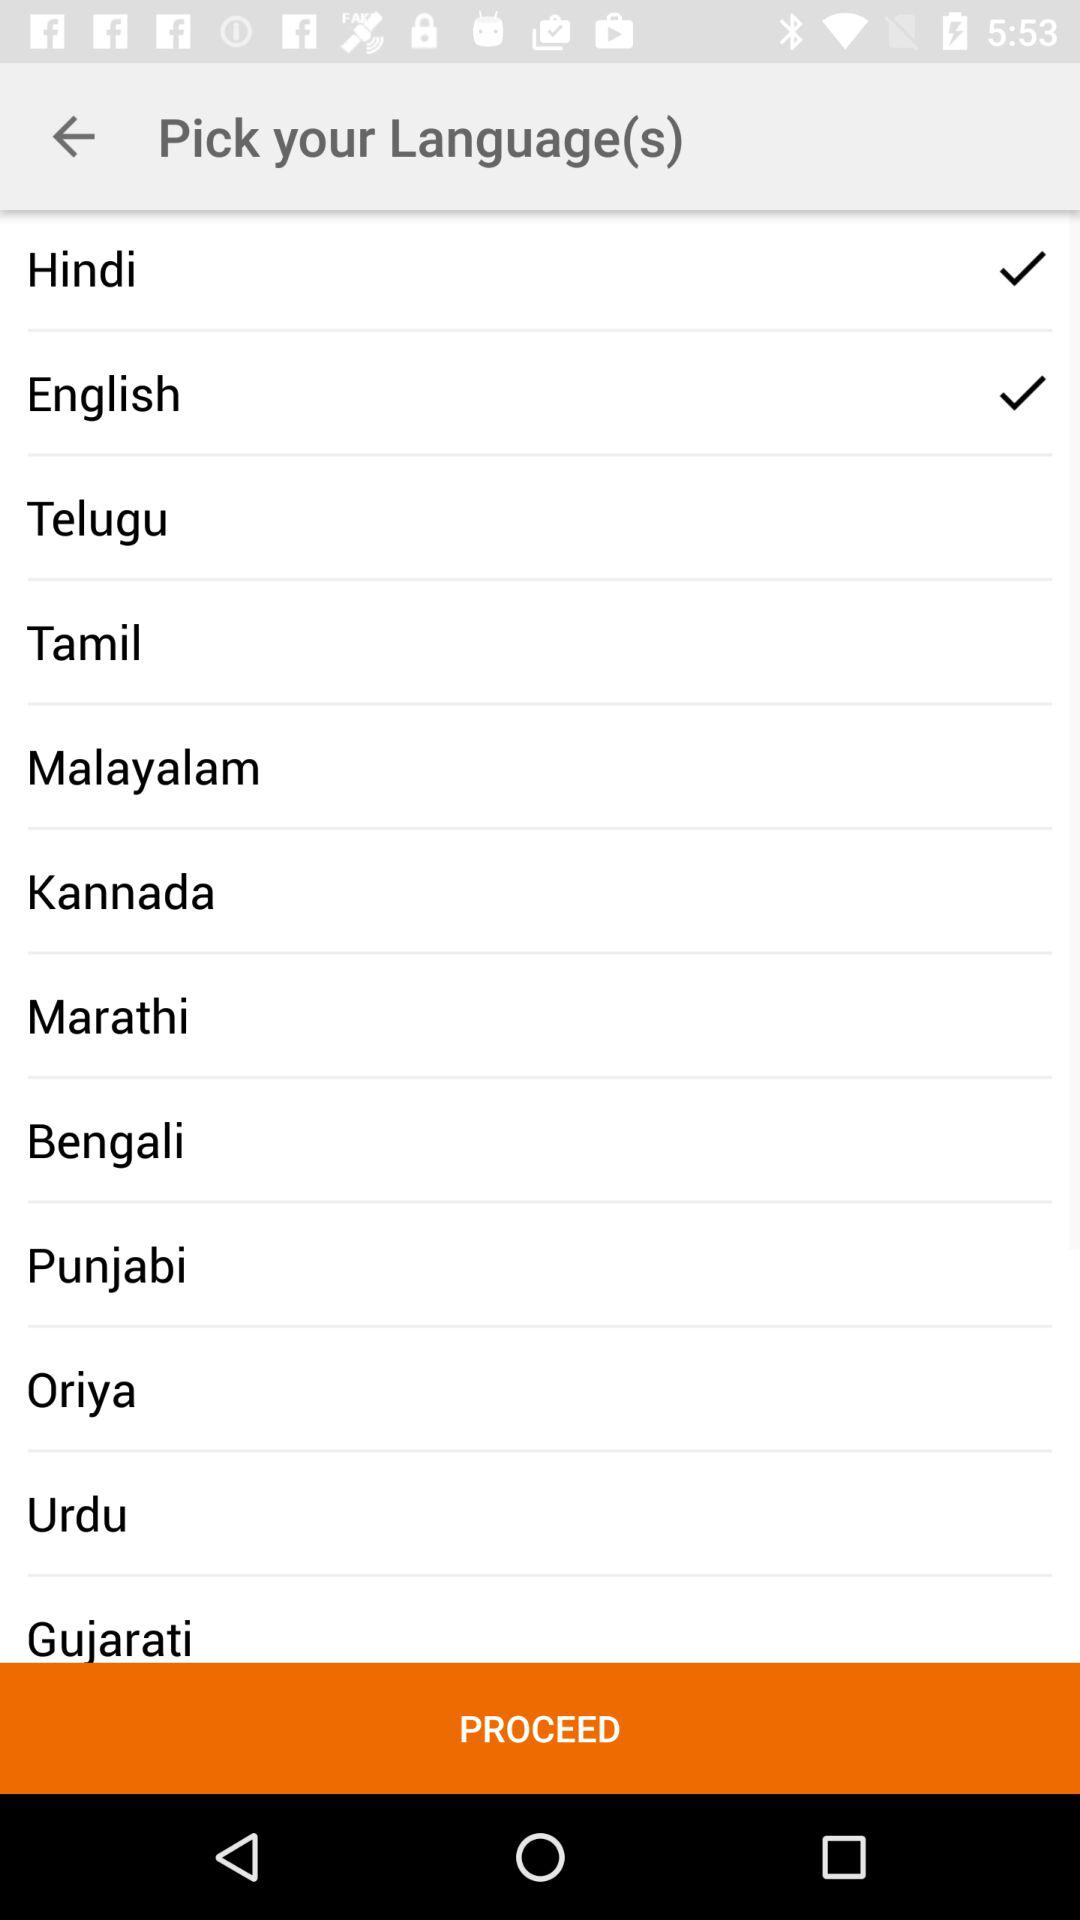How many languages have a check mark next to them?
Answer the question using a single word or phrase. 2 